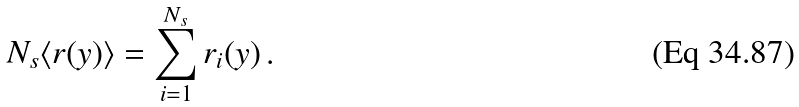<formula> <loc_0><loc_0><loc_500><loc_500>N _ { s } \langle r ( y ) \rangle = \sum _ { i = 1 } ^ { N _ { s } } r _ { i } ( y ) \, .</formula> 